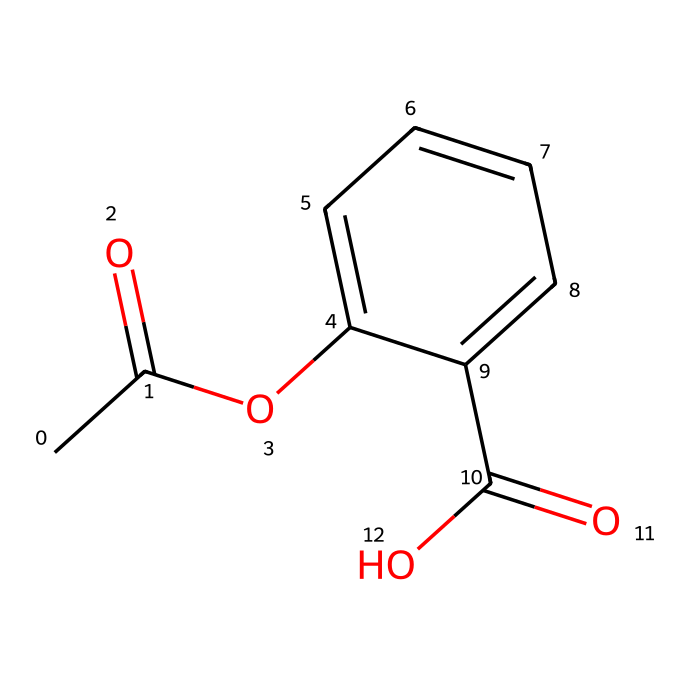What is the main functional group present in this chemical structure? The main functional group in the chemical structure is the ester group, as indicated by the presence of the carbonyl (C=O) adjacent to an oxygen atom (O) connected to a carbon chain.
Answer: ester How many carbon atoms are present in this chemical? By counting the carbon atoms in the SMILES representation, there are eight carbon atoms total, including those in the ester and carboxylic acid groups.
Answer: eight Does this chemical exhibit geometric isomerism? This chemical exhibits geometric isomerism due to the presence of a double bond between carbons and different substituents on either side of that double bond, allowing for both cis and trans isomers.
Answer: yes What type of isomerism is exhibited by the presence of the double bond in this chemical? The double bond leads to geometric (cis-trans) isomerism, which refers to isomers having different spatial arrangements due to restricted rotation around the double bond.
Answer: geometric What is the type of the terminal functional group on this chemical structure? The terminal functional group is a carboxylic acid group, identifiable from the -COOH structure at one end of the molecule.
Answer: carboxylic acid How many rings are present in this chemical structure? The SMILES structure does not indicate any cyclic (ring) components, as it exclusively describes a linear arrangement of atoms without any closed loops.
Answer: zero 